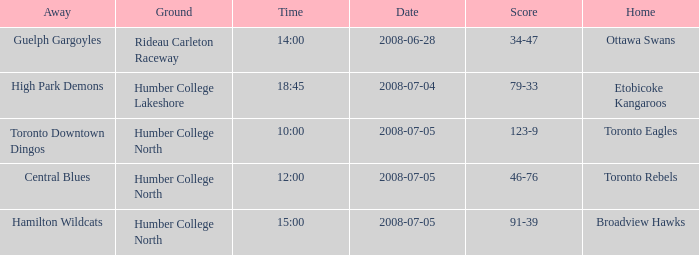What is the Ground with an Away that is central blues? Humber College North. 